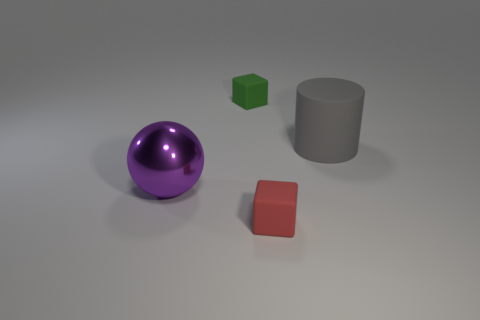Subtract all red blocks. How many blocks are left? 1 Subtract all cylinders. How many objects are left? 3 Add 2 large purple spheres. How many objects exist? 6 Subtract all blue blocks. Subtract all blue balls. How many blocks are left? 2 Add 4 metal objects. How many metal objects exist? 5 Subtract 1 red cubes. How many objects are left? 3 Subtract all purple balls. How many cyan cylinders are left? 0 Subtract all green things. Subtract all rubber cubes. How many objects are left? 1 Add 3 gray rubber cylinders. How many gray rubber cylinders are left? 4 